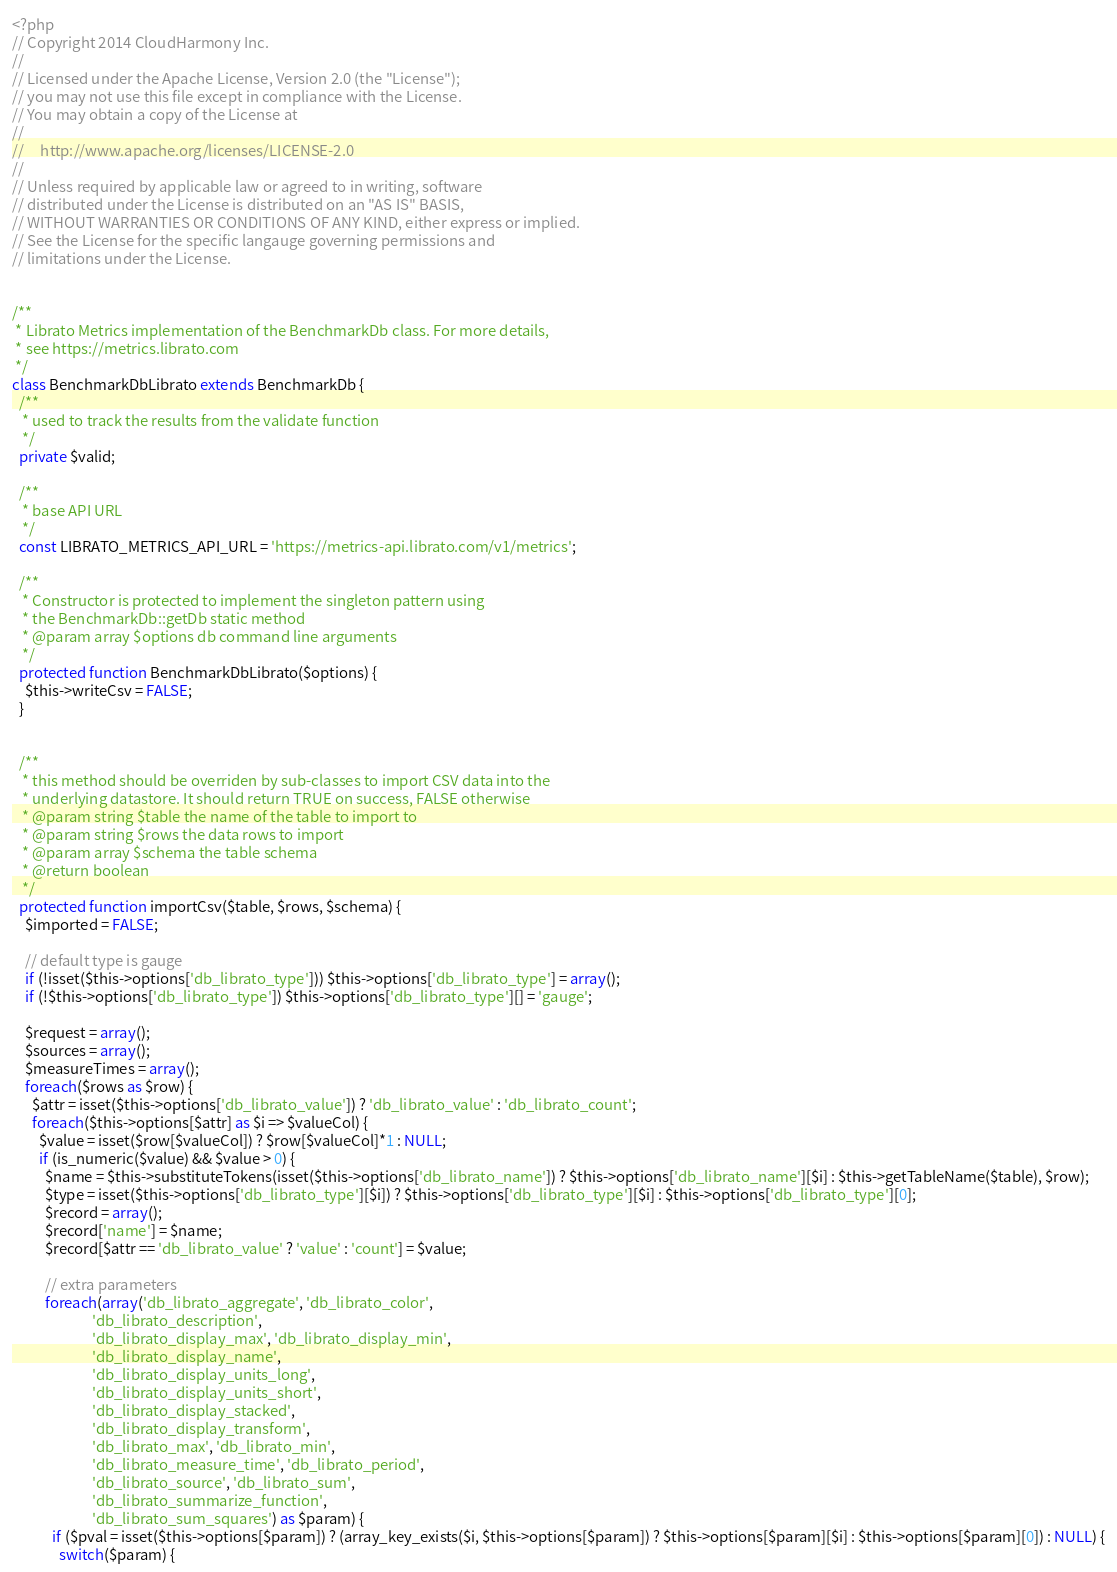Convert code to text. <code><loc_0><loc_0><loc_500><loc_500><_PHP_><?php
// Copyright 2014 CloudHarmony Inc.
// 
// Licensed under the Apache License, Version 2.0 (the "License");
// you may not use this file except in compliance with the License.
// You may obtain a copy of the License at
// 
//     http://www.apache.org/licenses/LICENSE-2.0
// 
// Unless required by applicable law or agreed to in writing, software
// distributed under the License is distributed on an "AS IS" BASIS,
// WITHOUT WARRANTIES OR CONDITIONS OF ANY KIND, either express or implied.
// See the License for the specific langauge governing permissions and
// limitations under the License.


/**
 * Librato Metrics implementation of the BenchmarkDb class. For more details,
 * see https://metrics.librato.com
 */
class BenchmarkDbLibrato extends BenchmarkDb {
  /**
   * used to track the results from the validate function
   */
  private $valid;
  
  /**
   * base API URL
   */
  const LIBRATO_METRICS_API_URL = 'https://metrics-api.librato.com/v1/metrics';
  
  /**
   * Constructor is protected to implement the singleton pattern using 
   * the BenchmarkDb::getDb static method
   * @param array $options db command line arguments
   */
  protected function BenchmarkDbLibrato($options) {
    $this->writeCsv = FALSE;
  }

  
  /**
   * this method should be overriden by sub-classes to import CSV data into the 
   * underlying datastore. It should return TRUE on success, FALSE otherwise
   * @param string $table the name of the table to import to
   * @param string $rows the data rows to import
   * @param array $schema the table schema
   * @return boolean
   */
  protected function importCsv($table, $rows, $schema) {
    $imported = FALSE;
    
    // default type is gauge
    if (!isset($this->options['db_librato_type'])) $this->options['db_librato_type'] = array();
    if (!$this->options['db_librato_type']) $this->options['db_librato_type'][] = 'gauge';
    
    $request = array();
    $sources = array();
    $measureTimes = array();
    foreach($rows as $row) {
      $attr = isset($this->options['db_librato_value']) ? 'db_librato_value' : 'db_librato_count';
      foreach($this->options[$attr] as $i => $valueCol) {
        $value = isset($row[$valueCol]) ? $row[$valueCol]*1 : NULL;
        if (is_numeric($value) && $value > 0) {
          $name = $this->substituteTokens(isset($this->options['db_librato_name']) ? $this->options['db_librato_name'][$i] : $this->getTableName($table), $row);
          $type = isset($this->options['db_librato_type'][$i]) ? $this->options['db_librato_type'][$i] : $this->options['db_librato_type'][0];
          $record = array();
          $record['name'] = $name;
          $record[$attr == 'db_librato_value' ? 'value' : 'count'] = $value;
          
          // extra parameters
          foreach(array('db_librato_aggregate', 'db_librato_color', 
                        'db_librato_description', 
                        'db_librato_display_max', 'db_librato_display_min',
                        'db_librato_display_name', 
                        'db_librato_display_units_long',
                        'db_librato_display_units_short',
                        'db_librato_display_stacked',
                        'db_librato_display_transform',
                        'db_librato_max', 'db_librato_min',
                        'db_librato_measure_time', 'db_librato_period', 
                        'db_librato_source', 'db_librato_sum', 
                        'db_librato_summarize_function',
                        'db_librato_sum_squares') as $param) {
            if ($pval = isset($this->options[$param]) ? (array_key_exists($i, $this->options[$param]) ? $this->options[$param][$i] : $this->options[$param][0]) : NULL) {
              switch($param) {</code> 